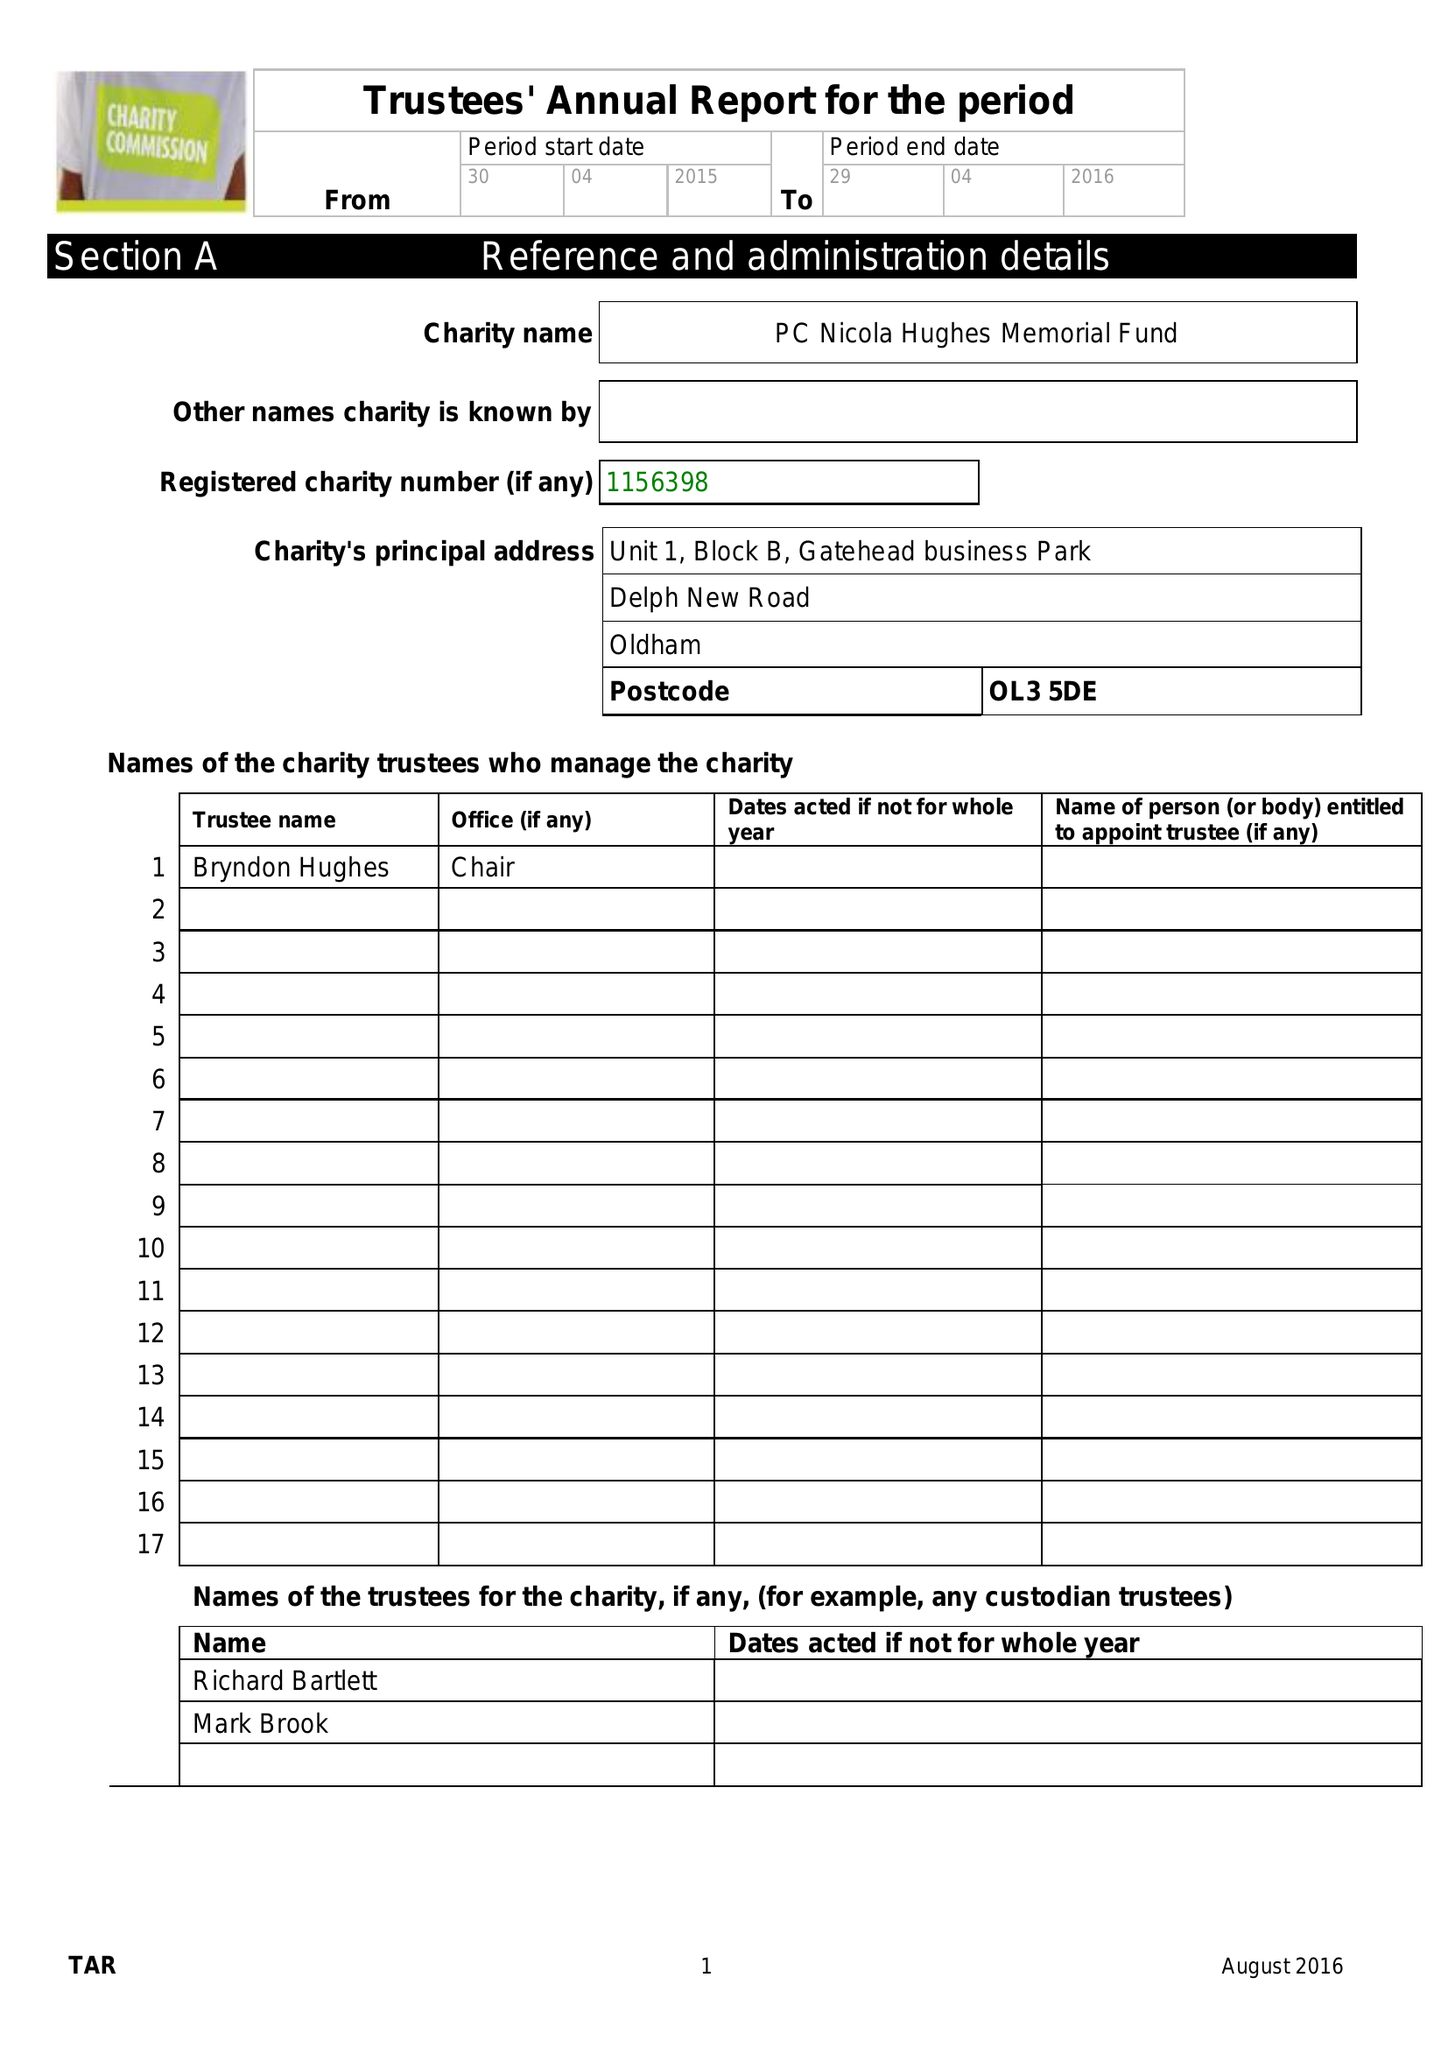What is the value for the charity_name?
Answer the question using a single word or phrase. Pc Nicola Hughes Memorial Fund 